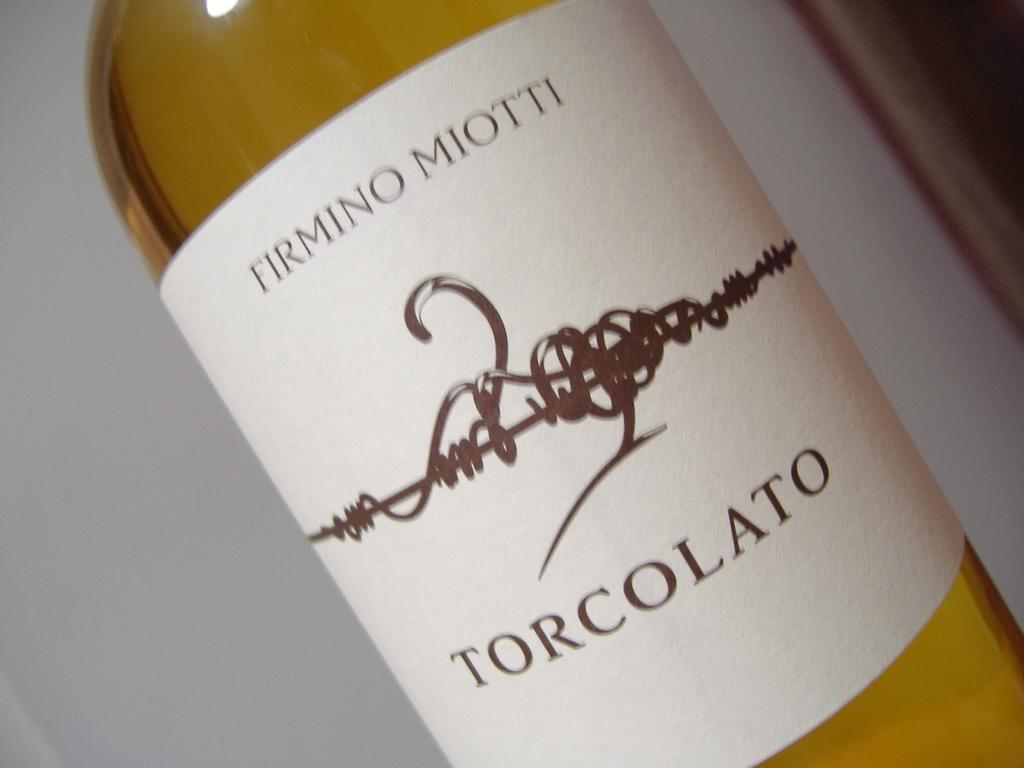<image>
Share a concise interpretation of the image provided. A Firmino Miotti Torcolato wine with a white label. 